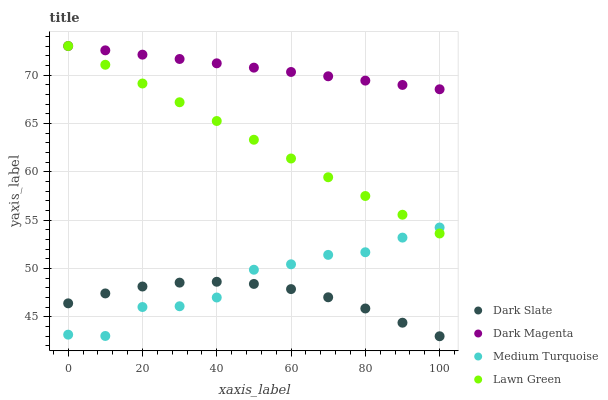Does Dark Slate have the minimum area under the curve?
Answer yes or no. Yes. Does Dark Magenta have the maximum area under the curve?
Answer yes or no. Yes. Does Medium Turquoise have the minimum area under the curve?
Answer yes or no. No. Does Medium Turquoise have the maximum area under the curve?
Answer yes or no. No. Is Dark Magenta the smoothest?
Answer yes or no. Yes. Is Medium Turquoise the roughest?
Answer yes or no. Yes. Is Medium Turquoise the smoothest?
Answer yes or no. No. Is Dark Magenta the roughest?
Answer yes or no. No. Does Dark Slate have the lowest value?
Answer yes or no. Yes. Does Medium Turquoise have the lowest value?
Answer yes or no. No. Does Lawn Green have the highest value?
Answer yes or no. Yes. Does Medium Turquoise have the highest value?
Answer yes or no. No. Is Dark Slate less than Lawn Green?
Answer yes or no. Yes. Is Dark Magenta greater than Dark Slate?
Answer yes or no. Yes. Does Dark Slate intersect Medium Turquoise?
Answer yes or no. Yes. Is Dark Slate less than Medium Turquoise?
Answer yes or no. No. Is Dark Slate greater than Medium Turquoise?
Answer yes or no. No. Does Dark Slate intersect Lawn Green?
Answer yes or no. No. 